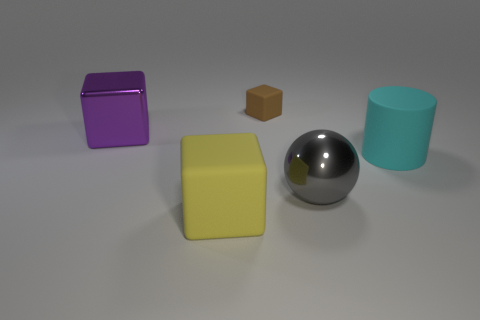Subtract all cyan cubes. Subtract all blue balls. How many cubes are left? 3 Add 1 big purple cylinders. How many objects exist? 6 Subtract all spheres. How many objects are left? 4 Add 4 purple things. How many purple things exist? 5 Subtract 0 green cylinders. How many objects are left? 5 Subtract all small brown matte objects. Subtract all brown rubber objects. How many objects are left? 3 Add 1 yellow rubber things. How many yellow rubber things are left? 2 